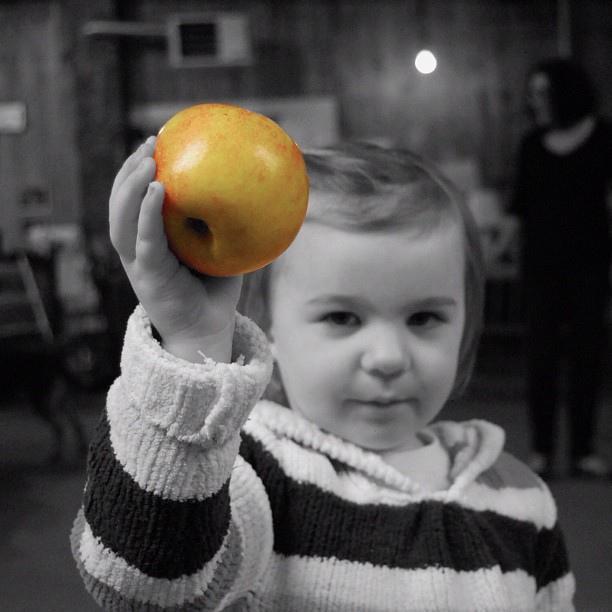How many people are in the photo?
Give a very brief answer. 2. 